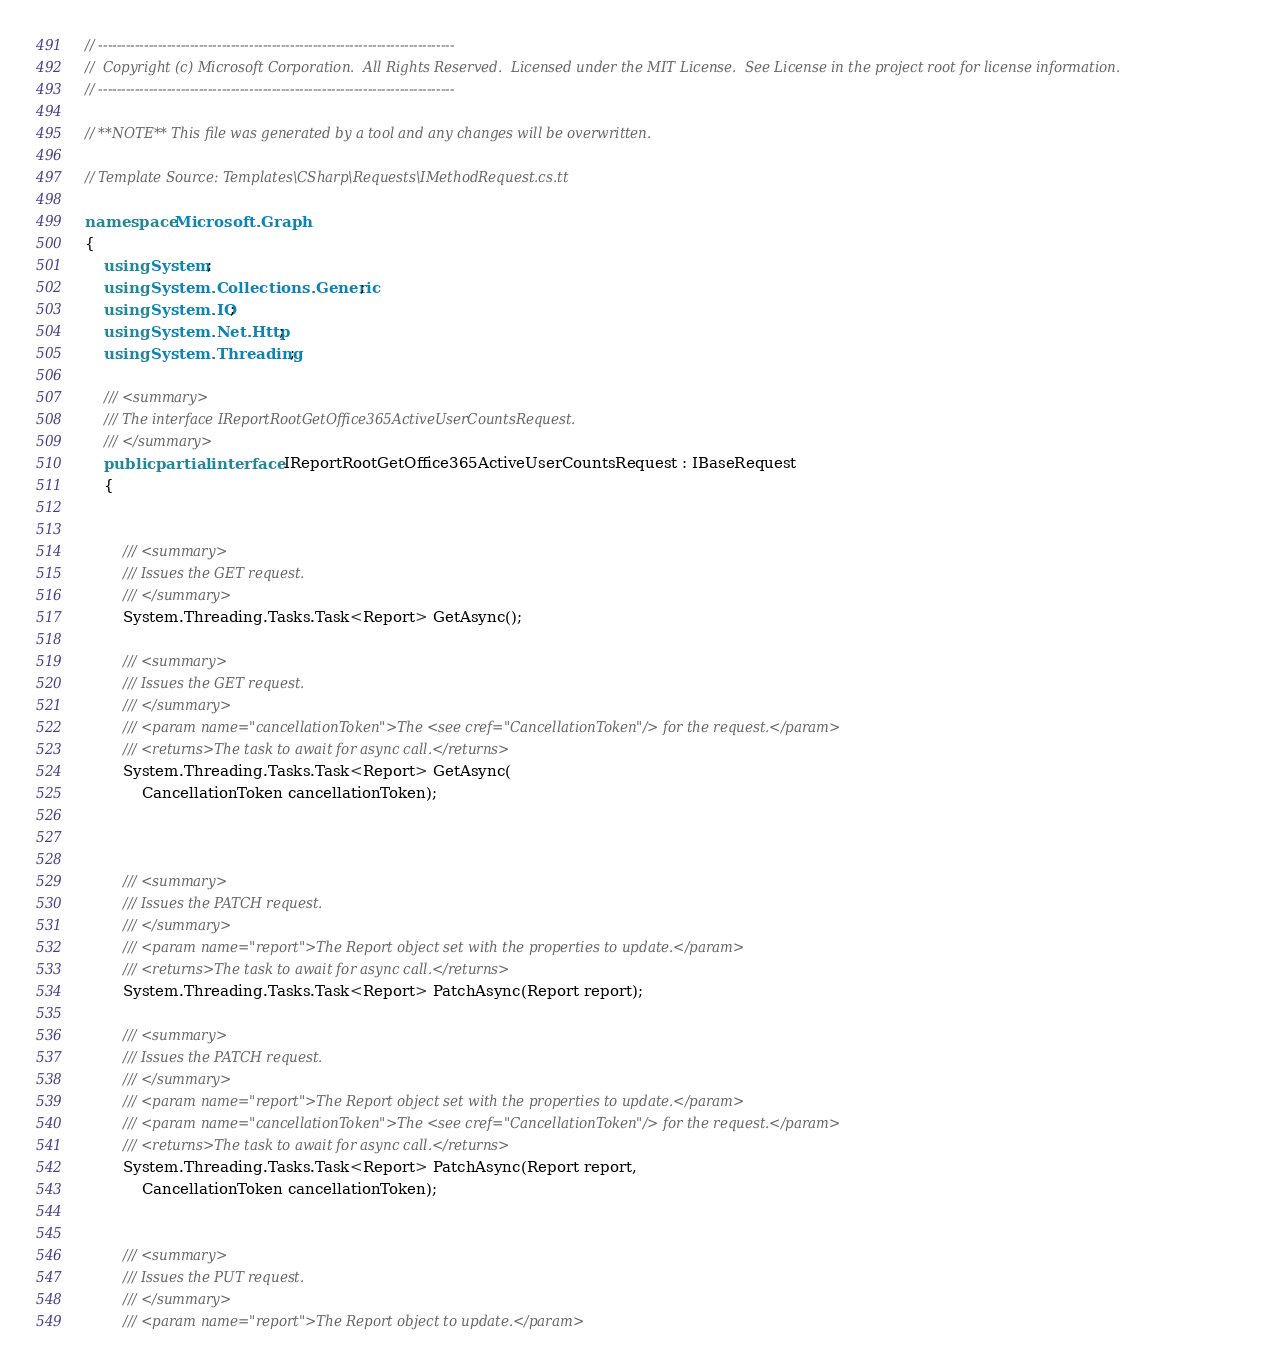Convert code to text. <code><loc_0><loc_0><loc_500><loc_500><_C#_>// ------------------------------------------------------------------------------
//  Copyright (c) Microsoft Corporation.  All Rights Reserved.  Licensed under the MIT License.  See License in the project root for license information.
// ------------------------------------------------------------------------------

// **NOTE** This file was generated by a tool and any changes will be overwritten.

// Template Source: Templates\CSharp\Requests\IMethodRequest.cs.tt

namespace Microsoft.Graph
{
    using System;
    using System.Collections.Generic;
    using System.IO;
    using System.Net.Http;
    using System.Threading;

    /// <summary>
    /// The interface IReportRootGetOffice365ActiveUserCountsRequest.
    /// </summary>
    public partial interface IReportRootGetOffice365ActiveUserCountsRequest : IBaseRequest
    {


        /// <summary>
        /// Issues the GET request.
        /// </summary>
        System.Threading.Tasks.Task<Report> GetAsync();
        
        /// <summary>
        /// Issues the GET request.
        /// </summary>
        /// <param name="cancellationToken">The <see cref="CancellationToken"/> for the request.</param>
        /// <returns>The task to await for async call.</returns>
        System.Threading.Tasks.Task<Report> GetAsync(
            CancellationToken cancellationToken);
  


        /// <summary>
        /// Issues the PATCH request.
        /// </summary>
        /// <param name="report">The Report object set with the properties to update.</param>
        /// <returns>The task to await for async call.</returns>
        System.Threading.Tasks.Task<Report> PatchAsync(Report report);

        /// <summary>
        /// Issues the PATCH request.
        /// </summary>
        /// <param name="report">The Report object set with the properties to update.</param>
        /// <param name="cancellationToken">The <see cref="CancellationToken"/> for the request.</param>
        /// <returns>The task to await for async call.</returns>
        System.Threading.Tasks.Task<Report> PatchAsync(Report report, 
            CancellationToken cancellationToken);
          

        /// <summary>
        /// Issues the PUT request.
        /// </summary>
        /// <param name="report">The Report object to update.</param></code> 